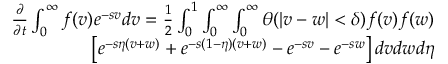<formula> <loc_0><loc_0><loc_500><loc_500>\begin{array} { r } { \begin{array} { r } { \frac { \partial } { \partial t } \int _ { 0 } ^ { \infty } f ( v ) e ^ { - s v } d v = \frac { 1 } { 2 } \int _ { 0 } ^ { 1 } \int _ { 0 } ^ { \infty } \int _ { 0 } ^ { \infty } \theta ( | v - w | < \delta ) f ( v ) f ( w ) } \\ { \left [ e ^ { - s \eta ( v + w ) } + e ^ { - s ( 1 - \eta ) ( v + w ) } - e ^ { - s v } - e ^ { - s w } \right ] d v d w d \eta } \end{array} } \end{array}</formula> 